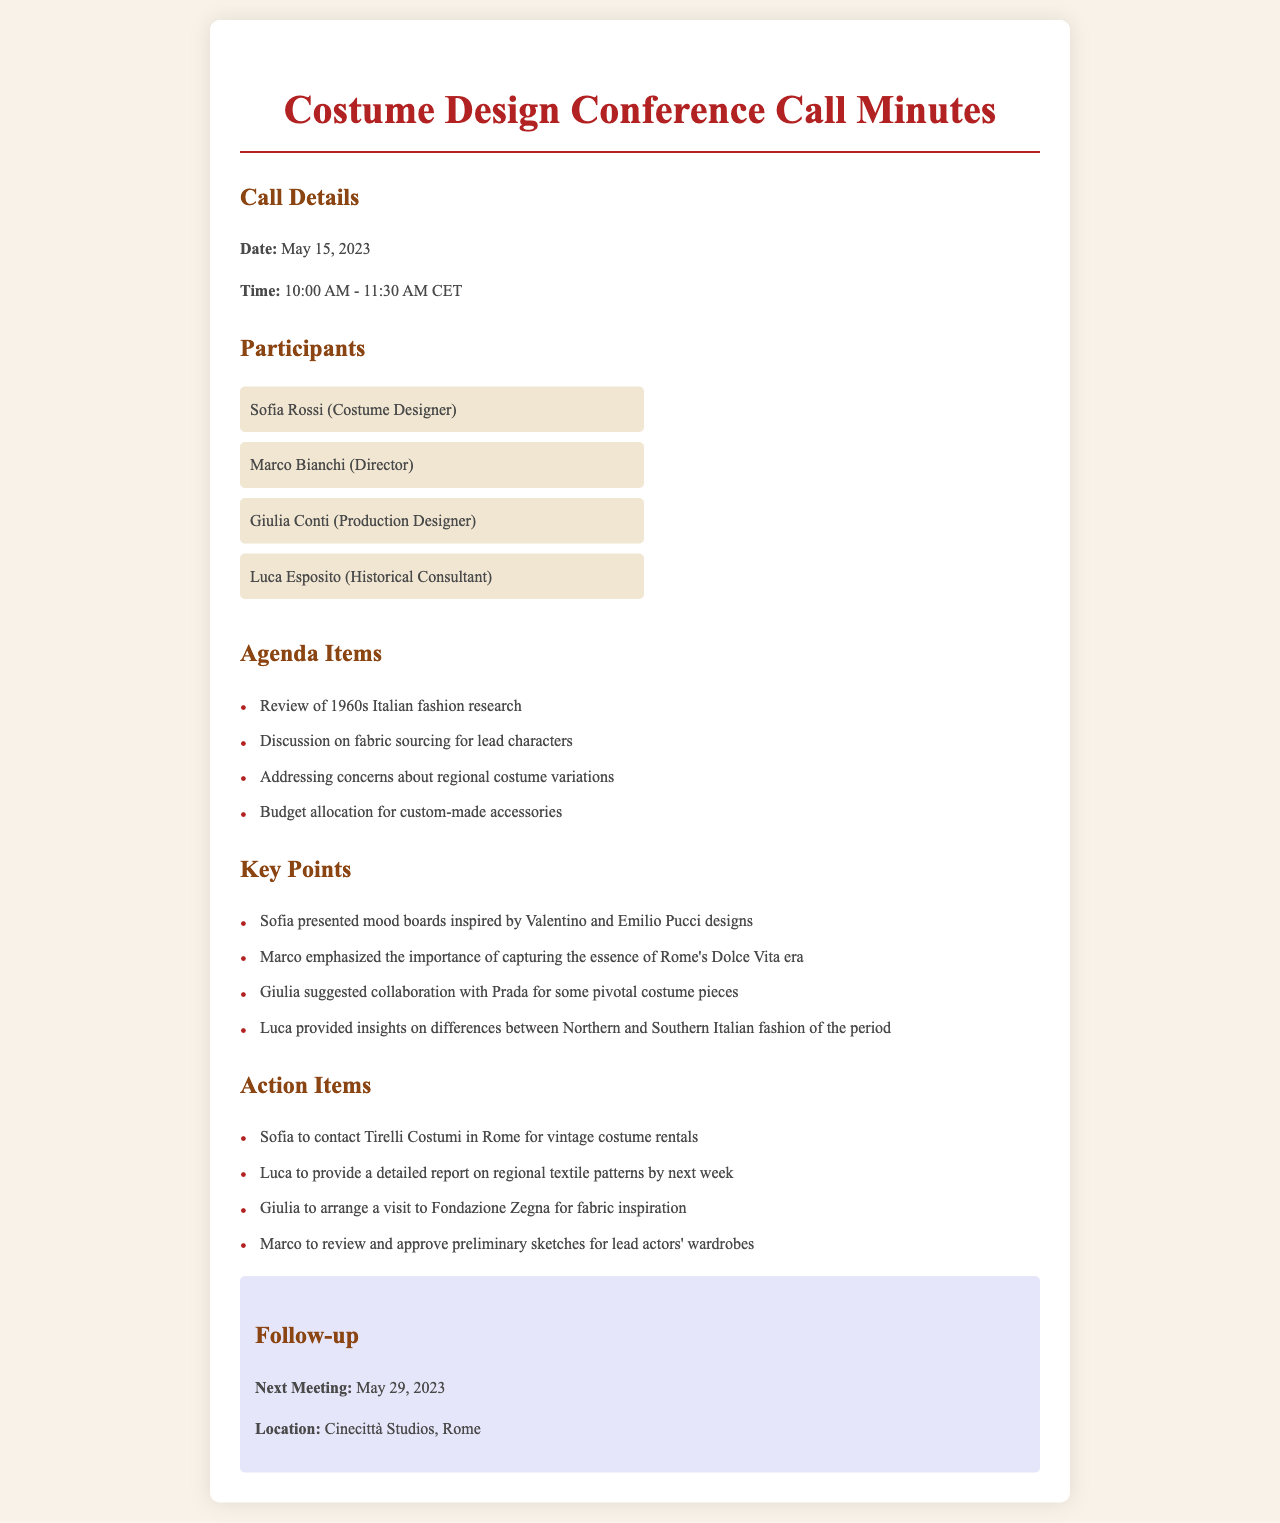What is the date of the conference call? The date is provided in the call details section of the document.
Answer: May 15, 2023 Who is the costume designer? The document lists participants, and the role of each individual is specified.
Answer: Sofia Rossi What was emphasized by Marco during the call? Marco's emphasis is mentioned in the key points section, highlighting the core theme of the discussion.
Answer: Capturing the essence of Rome's Dolce Vita era How long did the call last? The duration can be calculated from the start and end times mentioned in the call details.
Answer: 1 hour 30 minutes What is the next meeting's date? The follow-up section contains information about the scheduled next meeting.
Answer: May 29, 2023 Which organization is Sofia contacting for vintage costume rentals? This information is found in the action items that specify tasks assigned to participants.
Answer: Tirelli Costumi What area of fashion does Luca provide insights on? Luca's insights pertain to a specific aspect of Italian fashion mentioned in the key points.
Answer: Regional variations What collaboration was suggested by Giulia? Giulia's suggestion is noted in the key points related to costume design partnerships.
Answer: Collaboration with Prada 